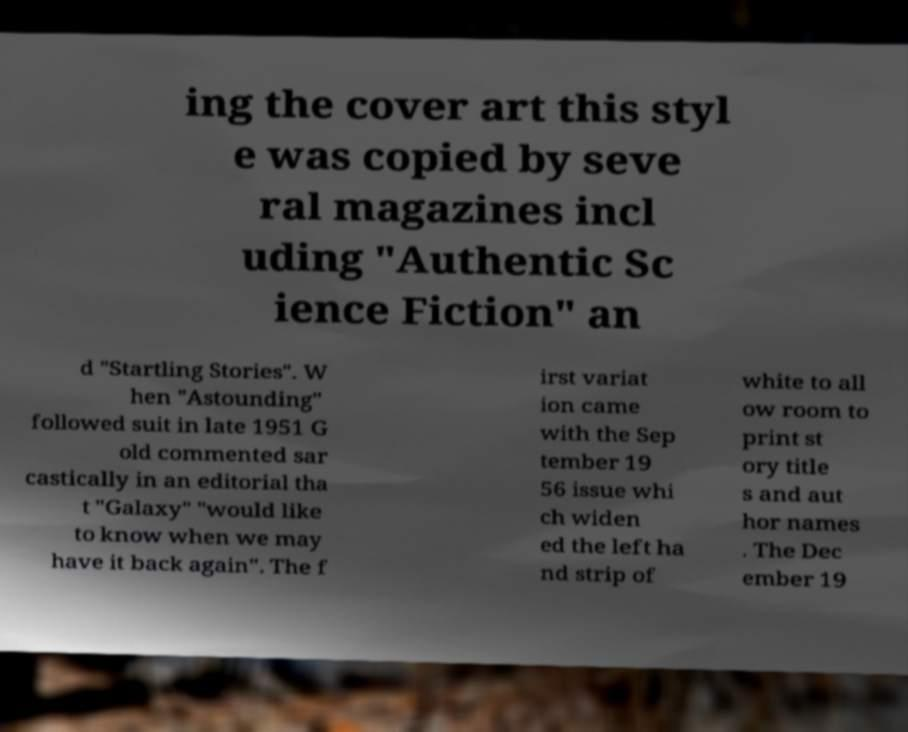What messages or text are displayed in this image? I need them in a readable, typed format. ing the cover art this styl e was copied by seve ral magazines incl uding "Authentic Sc ience Fiction" an d "Startling Stories". W hen "Astounding" followed suit in late 1951 G old commented sar castically in an editorial tha t "Galaxy" "would like to know when we may have it back again". The f irst variat ion came with the Sep tember 19 56 issue whi ch widen ed the left ha nd strip of white to all ow room to print st ory title s and aut hor names . The Dec ember 19 